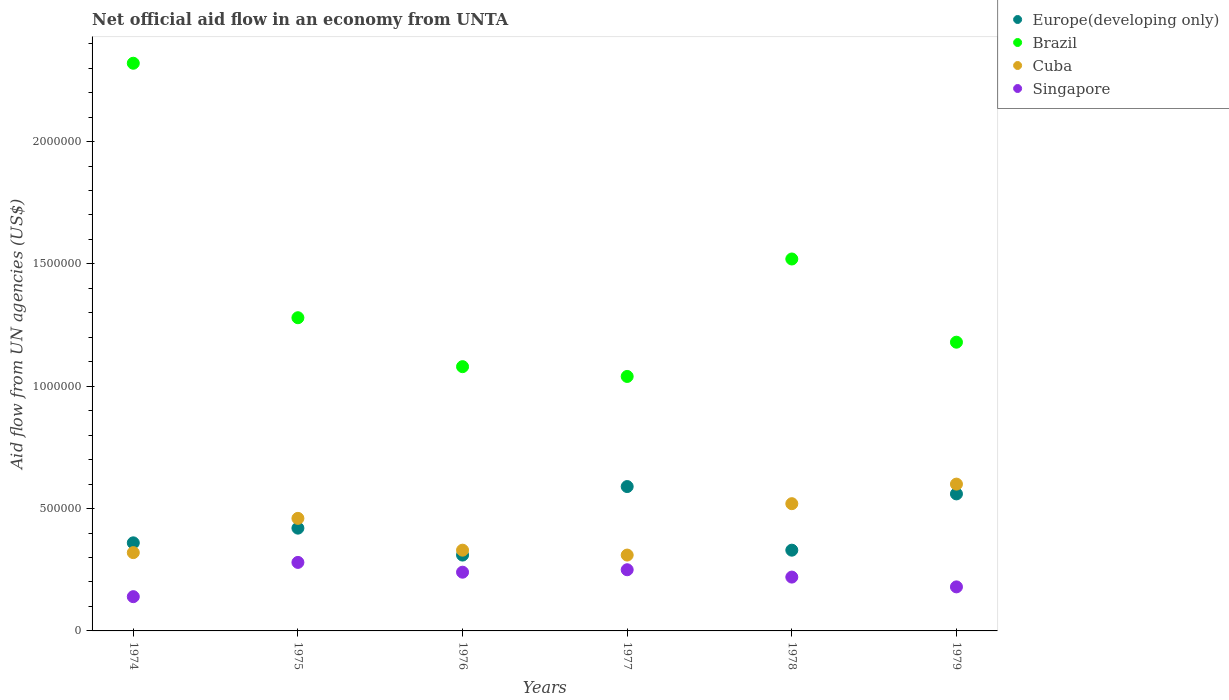What is the net official aid flow in Europe(developing only) in 1976?
Give a very brief answer. 3.10e+05. Across all years, what is the minimum net official aid flow in Cuba?
Make the answer very short. 3.10e+05. In which year was the net official aid flow in Cuba maximum?
Your response must be concise. 1979. In which year was the net official aid flow in Brazil minimum?
Your answer should be compact. 1977. What is the total net official aid flow in Brazil in the graph?
Provide a short and direct response. 8.42e+06. What is the difference between the net official aid flow in Singapore in 1979 and the net official aid flow in Cuba in 1977?
Make the answer very short. -1.30e+05. What is the average net official aid flow in Europe(developing only) per year?
Your answer should be very brief. 4.28e+05. What is the ratio of the net official aid flow in Europe(developing only) in 1976 to that in 1979?
Your response must be concise. 0.55. Is the net official aid flow in Europe(developing only) in 1974 less than that in 1977?
Keep it short and to the point. Yes. What is the difference between the highest and the lowest net official aid flow in Brazil?
Your response must be concise. 1.28e+06. In how many years, is the net official aid flow in Europe(developing only) greater than the average net official aid flow in Europe(developing only) taken over all years?
Your response must be concise. 2. Is the sum of the net official aid flow in Cuba in 1974 and 1979 greater than the maximum net official aid flow in Brazil across all years?
Offer a terse response. No. Is it the case that in every year, the sum of the net official aid flow in Cuba and net official aid flow in Europe(developing only)  is greater than the net official aid flow in Singapore?
Provide a short and direct response. Yes. Does the net official aid flow in Singapore monotonically increase over the years?
Your answer should be very brief. No. Is the net official aid flow in Singapore strictly less than the net official aid flow in Europe(developing only) over the years?
Offer a very short reply. Yes. How many dotlines are there?
Provide a short and direct response. 4. How many years are there in the graph?
Keep it short and to the point. 6. Does the graph contain any zero values?
Your answer should be compact. No. Does the graph contain grids?
Your answer should be compact. No. How many legend labels are there?
Your response must be concise. 4. What is the title of the graph?
Provide a succinct answer. Net official aid flow in an economy from UNTA. What is the label or title of the X-axis?
Offer a terse response. Years. What is the label or title of the Y-axis?
Give a very brief answer. Aid flow from UN agencies (US$). What is the Aid flow from UN agencies (US$) of Brazil in 1974?
Offer a terse response. 2.32e+06. What is the Aid flow from UN agencies (US$) of Cuba in 1974?
Provide a short and direct response. 3.20e+05. What is the Aid flow from UN agencies (US$) of Singapore in 1974?
Make the answer very short. 1.40e+05. What is the Aid flow from UN agencies (US$) of Europe(developing only) in 1975?
Make the answer very short. 4.20e+05. What is the Aid flow from UN agencies (US$) of Brazil in 1975?
Offer a very short reply. 1.28e+06. What is the Aid flow from UN agencies (US$) of Cuba in 1975?
Your answer should be compact. 4.60e+05. What is the Aid flow from UN agencies (US$) of Singapore in 1975?
Provide a succinct answer. 2.80e+05. What is the Aid flow from UN agencies (US$) in Europe(developing only) in 1976?
Provide a succinct answer. 3.10e+05. What is the Aid flow from UN agencies (US$) in Brazil in 1976?
Keep it short and to the point. 1.08e+06. What is the Aid flow from UN agencies (US$) of Cuba in 1976?
Offer a terse response. 3.30e+05. What is the Aid flow from UN agencies (US$) of Singapore in 1976?
Keep it short and to the point. 2.40e+05. What is the Aid flow from UN agencies (US$) in Europe(developing only) in 1977?
Ensure brevity in your answer.  5.90e+05. What is the Aid flow from UN agencies (US$) of Brazil in 1977?
Offer a terse response. 1.04e+06. What is the Aid flow from UN agencies (US$) in Brazil in 1978?
Keep it short and to the point. 1.52e+06. What is the Aid flow from UN agencies (US$) of Cuba in 1978?
Offer a terse response. 5.20e+05. What is the Aid flow from UN agencies (US$) of Singapore in 1978?
Provide a short and direct response. 2.20e+05. What is the Aid flow from UN agencies (US$) in Europe(developing only) in 1979?
Provide a succinct answer. 5.60e+05. What is the Aid flow from UN agencies (US$) of Brazil in 1979?
Ensure brevity in your answer.  1.18e+06. Across all years, what is the maximum Aid flow from UN agencies (US$) of Europe(developing only)?
Keep it short and to the point. 5.90e+05. Across all years, what is the maximum Aid flow from UN agencies (US$) of Brazil?
Your response must be concise. 2.32e+06. Across all years, what is the maximum Aid flow from UN agencies (US$) in Singapore?
Your answer should be very brief. 2.80e+05. Across all years, what is the minimum Aid flow from UN agencies (US$) in Brazil?
Keep it short and to the point. 1.04e+06. Across all years, what is the minimum Aid flow from UN agencies (US$) of Cuba?
Keep it short and to the point. 3.10e+05. Across all years, what is the minimum Aid flow from UN agencies (US$) of Singapore?
Offer a terse response. 1.40e+05. What is the total Aid flow from UN agencies (US$) in Europe(developing only) in the graph?
Provide a succinct answer. 2.57e+06. What is the total Aid flow from UN agencies (US$) in Brazil in the graph?
Ensure brevity in your answer.  8.42e+06. What is the total Aid flow from UN agencies (US$) in Cuba in the graph?
Offer a very short reply. 2.54e+06. What is the total Aid flow from UN agencies (US$) in Singapore in the graph?
Provide a short and direct response. 1.31e+06. What is the difference between the Aid flow from UN agencies (US$) of Europe(developing only) in 1974 and that in 1975?
Provide a short and direct response. -6.00e+04. What is the difference between the Aid flow from UN agencies (US$) in Brazil in 1974 and that in 1975?
Provide a succinct answer. 1.04e+06. What is the difference between the Aid flow from UN agencies (US$) of Europe(developing only) in 1974 and that in 1976?
Your answer should be compact. 5.00e+04. What is the difference between the Aid flow from UN agencies (US$) of Brazil in 1974 and that in 1976?
Provide a succinct answer. 1.24e+06. What is the difference between the Aid flow from UN agencies (US$) of Cuba in 1974 and that in 1976?
Provide a short and direct response. -10000. What is the difference between the Aid flow from UN agencies (US$) in Europe(developing only) in 1974 and that in 1977?
Make the answer very short. -2.30e+05. What is the difference between the Aid flow from UN agencies (US$) of Brazil in 1974 and that in 1977?
Ensure brevity in your answer.  1.28e+06. What is the difference between the Aid flow from UN agencies (US$) in Brazil in 1974 and that in 1978?
Your answer should be very brief. 8.00e+05. What is the difference between the Aid flow from UN agencies (US$) of Cuba in 1974 and that in 1978?
Your response must be concise. -2.00e+05. What is the difference between the Aid flow from UN agencies (US$) of Europe(developing only) in 1974 and that in 1979?
Offer a very short reply. -2.00e+05. What is the difference between the Aid flow from UN agencies (US$) of Brazil in 1974 and that in 1979?
Your response must be concise. 1.14e+06. What is the difference between the Aid flow from UN agencies (US$) in Cuba in 1974 and that in 1979?
Ensure brevity in your answer.  -2.80e+05. What is the difference between the Aid flow from UN agencies (US$) of Europe(developing only) in 1975 and that in 1976?
Your answer should be very brief. 1.10e+05. What is the difference between the Aid flow from UN agencies (US$) of Cuba in 1975 and that in 1976?
Make the answer very short. 1.30e+05. What is the difference between the Aid flow from UN agencies (US$) of Cuba in 1975 and that in 1977?
Ensure brevity in your answer.  1.50e+05. What is the difference between the Aid flow from UN agencies (US$) in Brazil in 1975 and that in 1978?
Give a very brief answer. -2.40e+05. What is the difference between the Aid flow from UN agencies (US$) of Singapore in 1975 and that in 1978?
Provide a succinct answer. 6.00e+04. What is the difference between the Aid flow from UN agencies (US$) of Europe(developing only) in 1975 and that in 1979?
Offer a very short reply. -1.40e+05. What is the difference between the Aid flow from UN agencies (US$) of Brazil in 1975 and that in 1979?
Provide a short and direct response. 1.00e+05. What is the difference between the Aid flow from UN agencies (US$) of Cuba in 1975 and that in 1979?
Offer a very short reply. -1.40e+05. What is the difference between the Aid flow from UN agencies (US$) in Europe(developing only) in 1976 and that in 1977?
Offer a very short reply. -2.80e+05. What is the difference between the Aid flow from UN agencies (US$) of Brazil in 1976 and that in 1977?
Your answer should be compact. 4.00e+04. What is the difference between the Aid flow from UN agencies (US$) of Europe(developing only) in 1976 and that in 1978?
Keep it short and to the point. -2.00e+04. What is the difference between the Aid flow from UN agencies (US$) of Brazil in 1976 and that in 1978?
Your answer should be very brief. -4.40e+05. What is the difference between the Aid flow from UN agencies (US$) in Singapore in 1976 and that in 1978?
Give a very brief answer. 2.00e+04. What is the difference between the Aid flow from UN agencies (US$) in Europe(developing only) in 1976 and that in 1979?
Keep it short and to the point. -2.50e+05. What is the difference between the Aid flow from UN agencies (US$) of Singapore in 1976 and that in 1979?
Give a very brief answer. 6.00e+04. What is the difference between the Aid flow from UN agencies (US$) in Europe(developing only) in 1977 and that in 1978?
Ensure brevity in your answer.  2.60e+05. What is the difference between the Aid flow from UN agencies (US$) of Brazil in 1977 and that in 1978?
Provide a short and direct response. -4.80e+05. What is the difference between the Aid flow from UN agencies (US$) of Europe(developing only) in 1977 and that in 1979?
Make the answer very short. 3.00e+04. What is the difference between the Aid flow from UN agencies (US$) in Brazil in 1977 and that in 1979?
Give a very brief answer. -1.40e+05. What is the difference between the Aid flow from UN agencies (US$) of Singapore in 1977 and that in 1979?
Give a very brief answer. 7.00e+04. What is the difference between the Aid flow from UN agencies (US$) of Europe(developing only) in 1978 and that in 1979?
Keep it short and to the point. -2.30e+05. What is the difference between the Aid flow from UN agencies (US$) of Singapore in 1978 and that in 1979?
Provide a succinct answer. 4.00e+04. What is the difference between the Aid flow from UN agencies (US$) in Europe(developing only) in 1974 and the Aid flow from UN agencies (US$) in Brazil in 1975?
Keep it short and to the point. -9.20e+05. What is the difference between the Aid flow from UN agencies (US$) in Europe(developing only) in 1974 and the Aid flow from UN agencies (US$) in Cuba in 1975?
Give a very brief answer. -1.00e+05. What is the difference between the Aid flow from UN agencies (US$) in Europe(developing only) in 1974 and the Aid flow from UN agencies (US$) in Singapore in 1975?
Provide a short and direct response. 8.00e+04. What is the difference between the Aid flow from UN agencies (US$) of Brazil in 1974 and the Aid flow from UN agencies (US$) of Cuba in 1975?
Provide a succinct answer. 1.86e+06. What is the difference between the Aid flow from UN agencies (US$) in Brazil in 1974 and the Aid flow from UN agencies (US$) in Singapore in 1975?
Make the answer very short. 2.04e+06. What is the difference between the Aid flow from UN agencies (US$) in Europe(developing only) in 1974 and the Aid flow from UN agencies (US$) in Brazil in 1976?
Provide a succinct answer. -7.20e+05. What is the difference between the Aid flow from UN agencies (US$) of Europe(developing only) in 1974 and the Aid flow from UN agencies (US$) of Cuba in 1976?
Provide a short and direct response. 3.00e+04. What is the difference between the Aid flow from UN agencies (US$) of Brazil in 1974 and the Aid flow from UN agencies (US$) of Cuba in 1976?
Ensure brevity in your answer.  1.99e+06. What is the difference between the Aid flow from UN agencies (US$) of Brazil in 1974 and the Aid flow from UN agencies (US$) of Singapore in 1976?
Provide a succinct answer. 2.08e+06. What is the difference between the Aid flow from UN agencies (US$) of Cuba in 1974 and the Aid flow from UN agencies (US$) of Singapore in 1976?
Give a very brief answer. 8.00e+04. What is the difference between the Aid flow from UN agencies (US$) in Europe(developing only) in 1974 and the Aid flow from UN agencies (US$) in Brazil in 1977?
Offer a terse response. -6.80e+05. What is the difference between the Aid flow from UN agencies (US$) of Europe(developing only) in 1974 and the Aid flow from UN agencies (US$) of Singapore in 1977?
Offer a terse response. 1.10e+05. What is the difference between the Aid flow from UN agencies (US$) of Brazil in 1974 and the Aid flow from UN agencies (US$) of Cuba in 1977?
Provide a succinct answer. 2.01e+06. What is the difference between the Aid flow from UN agencies (US$) in Brazil in 1974 and the Aid flow from UN agencies (US$) in Singapore in 1977?
Keep it short and to the point. 2.07e+06. What is the difference between the Aid flow from UN agencies (US$) in Europe(developing only) in 1974 and the Aid flow from UN agencies (US$) in Brazil in 1978?
Your answer should be very brief. -1.16e+06. What is the difference between the Aid flow from UN agencies (US$) of Europe(developing only) in 1974 and the Aid flow from UN agencies (US$) of Cuba in 1978?
Offer a very short reply. -1.60e+05. What is the difference between the Aid flow from UN agencies (US$) of Brazil in 1974 and the Aid flow from UN agencies (US$) of Cuba in 1978?
Your answer should be very brief. 1.80e+06. What is the difference between the Aid flow from UN agencies (US$) of Brazil in 1974 and the Aid flow from UN agencies (US$) of Singapore in 1978?
Keep it short and to the point. 2.10e+06. What is the difference between the Aid flow from UN agencies (US$) in Europe(developing only) in 1974 and the Aid flow from UN agencies (US$) in Brazil in 1979?
Provide a succinct answer. -8.20e+05. What is the difference between the Aid flow from UN agencies (US$) of Europe(developing only) in 1974 and the Aid flow from UN agencies (US$) of Singapore in 1979?
Offer a terse response. 1.80e+05. What is the difference between the Aid flow from UN agencies (US$) in Brazil in 1974 and the Aid flow from UN agencies (US$) in Cuba in 1979?
Provide a succinct answer. 1.72e+06. What is the difference between the Aid flow from UN agencies (US$) in Brazil in 1974 and the Aid flow from UN agencies (US$) in Singapore in 1979?
Ensure brevity in your answer.  2.14e+06. What is the difference between the Aid flow from UN agencies (US$) of Europe(developing only) in 1975 and the Aid flow from UN agencies (US$) of Brazil in 1976?
Offer a very short reply. -6.60e+05. What is the difference between the Aid flow from UN agencies (US$) in Europe(developing only) in 1975 and the Aid flow from UN agencies (US$) in Cuba in 1976?
Keep it short and to the point. 9.00e+04. What is the difference between the Aid flow from UN agencies (US$) in Europe(developing only) in 1975 and the Aid flow from UN agencies (US$) in Singapore in 1976?
Provide a succinct answer. 1.80e+05. What is the difference between the Aid flow from UN agencies (US$) in Brazil in 1975 and the Aid flow from UN agencies (US$) in Cuba in 1976?
Give a very brief answer. 9.50e+05. What is the difference between the Aid flow from UN agencies (US$) of Brazil in 1975 and the Aid flow from UN agencies (US$) of Singapore in 1976?
Offer a terse response. 1.04e+06. What is the difference between the Aid flow from UN agencies (US$) in Europe(developing only) in 1975 and the Aid flow from UN agencies (US$) in Brazil in 1977?
Your answer should be compact. -6.20e+05. What is the difference between the Aid flow from UN agencies (US$) in Europe(developing only) in 1975 and the Aid flow from UN agencies (US$) in Cuba in 1977?
Your answer should be compact. 1.10e+05. What is the difference between the Aid flow from UN agencies (US$) of Europe(developing only) in 1975 and the Aid flow from UN agencies (US$) of Singapore in 1977?
Your answer should be compact. 1.70e+05. What is the difference between the Aid flow from UN agencies (US$) of Brazil in 1975 and the Aid flow from UN agencies (US$) of Cuba in 1977?
Provide a succinct answer. 9.70e+05. What is the difference between the Aid flow from UN agencies (US$) of Brazil in 1975 and the Aid flow from UN agencies (US$) of Singapore in 1977?
Offer a very short reply. 1.03e+06. What is the difference between the Aid flow from UN agencies (US$) in Europe(developing only) in 1975 and the Aid flow from UN agencies (US$) in Brazil in 1978?
Your response must be concise. -1.10e+06. What is the difference between the Aid flow from UN agencies (US$) of Europe(developing only) in 1975 and the Aid flow from UN agencies (US$) of Cuba in 1978?
Your answer should be very brief. -1.00e+05. What is the difference between the Aid flow from UN agencies (US$) of Brazil in 1975 and the Aid flow from UN agencies (US$) of Cuba in 1978?
Provide a short and direct response. 7.60e+05. What is the difference between the Aid flow from UN agencies (US$) of Brazil in 1975 and the Aid flow from UN agencies (US$) of Singapore in 1978?
Ensure brevity in your answer.  1.06e+06. What is the difference between the Aid flow from UN agencies (US$) in Europe(developing only) in 1975 and the Aid flow from UN agencies (US$) in Brazil in 1979?
Your answer should be compact. -7.60e+05. What is the difference between the Aid flow from UN agencies (US$) of Brazil in 1975 and the Aid flow from UN agencies (US$) of Cuba in 1979?
Give a very brief answer. 6.80e+05. What is the difference between the Aid flow from UN agencies (US$) in Brazil in 1975 and the Aid flow from UN agencies (US$) in Singapore in 1979?
Give a very brief answer. 1.10e+06. What is the difference between the Aid flow from UN agencies (US$) in Cuba in 1975 and the Aid flow from UN agencies (US$) in Singapore in 1979?
Your answer should be very brief. 2.80e+05. What is the difference between the Aid flow from UN agencies (US$) of Europe(developing only) in 1976 and the Aid flow from UN agencies (US$) of Brazil in 1977?
Your answer should be compact. -7.30e+05. What is the difference between the Aid flow from UN agencies (US$) of Brazil in 1976 and the Aid flow from UN agencies (US$) of Cuba in 1977?
Ensure brevity in your answer.  7.70e+05. What is the difference between the Aid flow from UN agencies (US$) in Brazil in 1976 and the Aid flow from UN agencies (US$) in Singapore in 1977?
Your response must be concise. 8.30e+05. What is the difference between the Aid flow from UN agencies (US$) in Europe(developing only) in 1976 and the Aid flow from UN agencies (US$) in Brazil in 1978?
Keep it short and to the point. -1.21e+06. What is the difference between the Aid flow from UN agencies (US$) in Brazil in 1976 and the Aid flow from UN agencies (US$) in Cuba in 1978?
Offer a very short reply. 5.60e+05. What is the difference between the Aid flow from UN agencies (US$) of Brazil in 1976 and the Aid flow from UN agencies (US$) of Singapore in 1978?
Ensure brevity in your answer.  8.60e+05. What is the difference between the Aid flow from UN agencies (US$) of Europe(developing only) in 1976 and the Aid flow from UN agencies (US$) of Brazil in 1979?
Offer a very short reply. -8.70e+05. What is the difference between the Aid flow from UN agencies (US$) in Europe(developing only) in 1976 and the Aid flow from UN agencies (US$) in Cuba in 1979?
Your response must be concise. -2.90e+05. What is the difference between the Aid flow from UN agencies (US$) in Brazil in 1976 and the Aid flow from UN agencies (US$) in Singapore in 1979?
Offer a very short reply. 9.00e+05. What is the difference between the Aid flow from UN agencies (US$) in Europe(developing only) in 1977 and the Aid flow from UN agencies (US$) in Brazil in 1978?
Make the answer very short. -9.30e+05. What is the difference between the Aid flow from UN agencies (US$) of Europe(developing only) in 1977 and the Aid flow from UN agencies (US$) of Cuba in 1978?
Offer a very short reply. 7.00e+04. What is the difference between the Aid flow from UN agencies (US$) of Europe(developing only) in 1977 and the Aid flow from UN agencies (US$) of Singapore in 1978?
Provide a succinct answer. 3.70e+05. What is the difference between the Aid flow from UN agencies (US$) of Brazil in 1977 and the Aid flow from UN agencies (US$) of Cuba in 1978?
Your answer should be very brief. 5.20e+05. What is the difference between the Aid flow from UN agencies (US$) in Brazil in 1977 and the Aid flow from UN agencies (US$) in Singapore in 1978?
Provide a succinct answer. 8.20e+05. What is the difference between the Aid flow from UN agencies (US$) in Europe(developing only) in 1977 and the Aid flow from UN agencies (US$) in Brazil in 1979?
Keep it short and to the point. -5.90e+05. What is the difference between the Aid flow from UN agencies (US$) of Europe(developing only) in 1977 and the Aid flow from UN agencies (US$) of Singapore in 1979?
Your answer should be compact. 4.10e+05. What is the difference between the Aid flow from UN agencies (US$) of Brazil in 1977 and the Aid flow from UN agencies (US$) of Singapore in 1979?
Offer a terse response. 8.60e+05. What is the difference between the Aid flow from UN agencies (US$) of Cuba in 1977 and the Aid flow from UN agencies (US$) of Singapore in 1979?
Your response must be concise. 1.30e+05. What is the difference between the Aid flow from UN agencies (US$) in Europe(developing only) in 1978 and the Aid flow from UN agencies (US$) in Brazil in 1979?
Your response must be concise. -8.50e+05. What is the difference between the Aid flow from UN agencies (US$) in Brazil in 1978 and the Aid flow from UN agencies (US$) in Cuba in 1979?
Offer a terse response. 9.20e+05. What is the difference between the Aid flow from UN agencies (US$) of Brazil in 1978 and the Aid flow from UN agencies (US$) of Singapore in 1979?
Keep it short and to the point. 1.34e+06. What is the average Aid flow from UN agencies (US$) of Europe(developing only) per year?
Your answer should be very brief. 4.28e+05. What is the average Aid flow from UN agencies (US$) of Brazil per year?
Make the answer very short. 1.40e+06. What is the average Aid flow from UN agencies (US$) of Cuba per year?
Provide a succinct answer. 4.23e+05. What is the average Aid flow from UN agencies (US$) in Singapore per year?
Ensure brevity in your answer.  2.18e+05. In the year 1974, what is the difference between the Aid flow from UN agencies (US$) of Europe(developing only) and Aid flow from UN agencies (US$) of Brazil?
Make the answer very short. -1.96e+06. In the year 1974, what is the difference between the Aid flow from UN agencies (US$) of Europe(developing only) and Aid flow from UN agencies (US$) of Cuba?
Give a very brief answer. 4.00e+04. In the year 1974, what is the difference between the Aid flow from UN agencies (US$) of Brazil and Aid flow from UN agencies (US$) of Singapore?
Ensure brevity in your answer.  2.18e+06. In the year 1975, what is the difference between the Aid flow from UN agencies (US$) in Europe(developing only) and Aid flow from UN agencies (US$) in Brazil?
Your response must be concise. -8.60e+05. In the year 1975, what is the difference between the Aid flow from UN agencies (US$) of Europe(developing only) and Aid flow from UN agencies (US$) of Cuba?
Your response must be concise. -4.00e+04. In the year 1975, what is the difference between the Aid flow from UN agencies (US$) in Europe(developing only) and Aid flow from UN agencies (US$) in Singapore?
Provide a short and direct response. 1.40e+05. In the year 1975, what is the difference between the Aid flow from UN agencies (US$) in Brazil and Aid flow from UN agencies (US$) in Cuba?
Your answer should be compact. 8.20e+05. In the year 1975, what is the difference between the Aid flow from UN agencies (US$) in Brazil and Aid flow from UN agencies (US$) in Singapore?
Provide a short and direct response. 1.00e+06. In the year 1975, what is the difference between the Aid flow from UN agencies (US$) in Cuba and Aid flow from UN agencies (US$) in Singapore?
Ensure brevity in your answer.  1.80e+05. In the year 1976, what is the difference between the Aid flow from UN agencies (US$) of Europe(developing only) and Aid flow from UN agencies (US$) of Brazil?
Offer a terse response. -7.70e+05. In the year 1976, what is the difference between the Aid flow from UN agencies (US$) in Europe(developing only) and Aid flow from UN agencies (US$) in Cuba?
Make the answer very short. -2.00e+04. In the year 1976, what is the difference between the Aid flow from UN agencies (US$) in Brazil and Aid flow from UN agencies (US$) in Cuba?
Offer a terse response. 7.50e+05. In the year 1976, what is the difference between the Aid flow from UN agencies (US$) of Brazil and Aid flow from UN agencies (US$) of Singapore?
Ensure brevity in your answer.  8.40e+05. In the year 1977, what is the difference between the Aid flow from UN agencies (US$) in Europe(developing only) and Aid flow from UN agencies (US$) in Brazil?
Provide a succinct answer. -4.50e+05. In the year 1977, what is the difference between the Aid flow from UN agencies (US$) of Brazil and Aid flow from UN agencies (US$) of Cuba?
Keep it short and to the point. 7.30e+05. In the year 1977, what is the difference between the Aid flow from UN agencies (US$) in Brazil and Aid flow from UN agencies (US$) in Singapore?
Offer a terse response. 7.90e+05. In the year 1978, what is the difference between the Aid flow from UN agencies (US$) in Europe(developing only) and Aid flow from UN agencies (US$) in Brazil?
Your response must be concise. -1.19e+06. In the year 1978, what is the difference between the Aid flow from UN agencies (US$) in Europe(developing only) and Aid flow from UN agencies (US$) in Cuba?
Your response must be concise. -1.90e+05. In the year 1978, what is the difference between the Aid flow from UN agencies (US$) of Europe(developing only) and Aid flow from UN agencies (US$) of Singapore?
Keep it short and to the point. 1.10e+05. In the year 1978, what is the difference between the Aid flow from UN agencies (US$) of Brazil and Aid flow from UN agencies (US$) of Cuba?
Your answer should be compact. 1.00e+06. In the year 1978, what is the difference between the Aid flow from UN agencies (US$) of Brazil and Aid flow from UN agencies (US$) of Singapore?
Your answer should be very brief. 1.30e+06. In the year 1979, what is the difference between the Aid flow from UN agencies (US$) of Europe(developing only) and Aid flow from UN agencies (US$) of Brazil?
Provide a succinct answer. -6.20e+05. In the year 1979, what is the difference between the Aid flow from UN agencies (US$) of Brazil and Aid flow from UN agencies (US$) of Cuba?
Make the answer very short. 5.80e+05. In the year 1979, what is the difference between the Aid flow from UN agencies (US$) in Brazil and Aid flow from UN agencies (US$) in Singapore?
Your response must be concise. 1.00e+06. In the year 1979, what is the difference between the Aid flow from UN agencies (US$) in Cuba and Aid flow from UN agencies (US$) in Singapore?
Your response must be concise. 4.20e+05. What is the ratio of the Aid flow from UN agencies (US$) of Brazil in 1974 to that in 1975?
Your answer should be very brief. 1.81. What is the ratio of the Aid flow from UN agencies (US$) of Cuba in 1974 to that in 1975?
Offer a very short reply. 0.7. What is the ratio of the Aid flow from UN agencies (US$) in Europe(developing only) in 1974 to that in 1976?
Provide a succinct answer. 1.16. What is the ratio of the Aid flow from UN agencies (US$) of Brazil in 1974 to that in 1976?
Your response must be concise. 2.15. What is the ratio of the Aid flow from UN agencies (US$) in Cuba in 1974 to that in 1976?
Offer a terse response. 0.97. What is the ratio of the Aid flow from UN agencies (US$) in Singapore in 1974 to that in 1976?
Offer a terse response. 0.58. What is the ratio of the Aid flow from UN agencies (US$) in Europe(developing only) in 1974 to that in 1977?
Your response must be concise. 0.61. What is the ratio of the Aid flow from UN agencies (US$) in Brazil in 1974 to that in 1977?
Your response must be concise. 2.23. What is the ratio of the Aid flow from UN agencies (US$) in Cuba in 1974 to that in 1977?
Keep it short and to the point. 1.03. What is the ratio of the Aid flow from UN agencies (US$) of Singapore in 1974 to that in 1977?
Make the answer very short. 0.56. What is the ratio of the Aid flow from UN agencies (US$) of Europe(developing only) in 1974 to that in 1978?
Give a very brief answer. 1.09. What is the ratio of the Aid flow from UN agencies (US$) of Brazil in 1974 to that in 1978?
Offer a very short reply. 1.53. What is the ratio of the Aid flow from UN agencies (US$) of Cuba in 1974 to that in 1978?
Offer a very short reply. 0.62. What is the ratio of the Aid flow from UN agencies (US$) in Singapore in 1974 to that in 1978?
Give a very brief answer. 0.64. What is the ratio of the Aid flow from UN agencies (US$) of Europe(developing only) in 1974 to that in 1979?
Your answer should be compact. 0.64. What is the ratio of the Aid flow from UN agencies (US$) of Brazil in 1974 to that in 1979?
Give a very brief answer. 1.97. What is the ratio of the Aid flow from UN agencies (US$) in Cuba in 1974 to that in 1979?
Your answer should be compact. 0.53. What is the ratio of the Aid flow from UN agencies (US$) of Singapore in 1974 to that in 1979?
Offer a very short reply. 0.78. What is the ratio of the Aid flow from UN agencies (US$) in Europe(developing only) in 1975 to that in 1976?
Give a very brief answer. 1.35. What is the ratio of the Aid flow from UN agencies (US$) of Brazil in 1975 to that in 1976?
Make the answer very short. 1.19. What is the ratio of the Aid flow from UN agencies (US$) in Cuba in 1975 to that in 1976?
Your response must be concise. 1.39. What is the ratio of the Aid flow from UN agencies (US$) in Singapore in 1975 to that in 1976?
Offer a very short reply. 1.17. What is the ratio of the Aid flow from UN agencies (US$) of Europe(developing only) in 1975 to that in 1977?
Your response must be concise. 0.71. What is the ratio of the Aid flow from UN agencies (US$) of Brazil in 1975 to that in 1977?
Make the answer very short. 1.23. What is the ratio of the Aid flow from UN agencies (US$) in Cuba in 1975 to that in 1977?
Offer a very short reply. 1.48. What is the ratio of the Aid flow from UN agencies (US$) of Singapore in 1975 to that in 1977?
Ensure brevity in your answer.  1.12. What is the ratio of the Aid flow from UN agencies (US$) in Europe(developing only) in 1975 to that in 1978?
Keep it short and to the point. 1.27. What is the ratio of the Aid flow from UN agencies (US$) in Brazil in 1975 to that in 1978?
Offer a very short reply. 0.84. What is the ratio of the Aid flow from UN agencies (US$) in Cuba in 1975 to that in 1978?
Offer a very short reply. 0.88. What is the ratio of the Aid flow from UN agencies (US$) of Singapore in 1975 to that in 1978?
Make the answer very short. 1.27. What is the ratio of the Aid flow from UN agencies (US$) in Brazil in 1975 to that in 1979?
Your response must be concise. 1.08. What is the ratio of the Aid flow from UN agencies (US$) in Cuba in 1975 to that in 1979?
Your response must be concise. 0.77. What is the ratio of the Aid flow from UN agencies (US$) in Singapore in 1975 to that in 1979?
Offer a very short reply. 1.56. What is the ratio of the Aid flow from UN agencies (US$) of Europe(developing only) in 1976 to that in 1977?
Provide a short and direct response. 0.53. What is the ratio of the Aid flow from UN agencies (US$) of Brazil in 1976 to that in 1977?
Provide a succinct answer. 1.04. What is the ratio of the Aid flow from UN agencies (US$) of Cuba in 1976 to that in 1977?
Your response must be concise. 1.06. What is the ratio of the Aid flow from UN agencies (US$) in Europe(developing only) in 1976 to that in 1978?
Your answer should be compact. 0.94. What is the ratio of the Aid flow from UN agencies (US$) of Brazil in 1976 to that in 1978?
Provide a succinct answer. 0.71. What is the ratio of the Aid flow from UN agencies (US$) of Cuba in 1976 to that in 1978?
Keep it short and to the point. 0.63. What is the ratio of the Aid flow from UN agencies (US$) of Singapore in 1976 to that in 1978?
Your answer should be compact. 1.09. What is the ratio of the Aid flow from UN agencies (US$) of Europe(developing only) in 1976 to that in 1979?
Keep it short and to the point. 0.55. What is the ratio of the Aid flow from UN agencies (US$) of Brazil in 1976 to that in 1979?
Ensure brevity in your answer.  0.92. What is the ratio of the Aid flow from UN agencies (US$) in Cuba in 1976 to that in 1979?
Make the answer very short. 0.55. What is the ratio of the Aid flow from UN agencies (US$) of Singapore in 1976 to that in 1979?
Provide a succinct answer. 1.33. What is the ratio of the Aid flow from UN agencies (US$) in Europe(developing only) in 1977 to that in 1978?
Offer a terse response. 1.79. What is the ratio of the Aid flow from UN agencies (US$) of Brazil in 1977 to that in 1978?
Ensure brevity in your answer.  0.68. What is the ratio of the Aid flow from UN agencies (US$) in Cuba in 1977 to that in 1978?
Give a very brief answer. 0.6. What is the ratio of the Aid flow from UN agencies (US$) of Singapore in 1977 to that in 1978?
Offer a terse response. 1.14. What is the ratio of the Aid flow from UN agencies (US$) of Europe(developing only) in 1977 to that in 1979?
Your answer should be compact. 1.05. What is the ratio of the Aid flow from UN agencies (US$) in Brazil in 1977 to that in 1979?
Keep it short and to the point. 0.88. What is the ratio of the Aid flow from UN agencies (US$) in Cuba in 1977 to that in 1979?
Ensure brevity in your answer.  0.52. What is the ratio of the Aid flow from UN agencies (US$) in Singapore in 1977 to that in 1979?
Your response must be concise. 1.39. What is the ratio of the Aid flow from UN agencies (US$) of Europe(developing only) in 1978 to that in 1979?
Give a very brief answer. 0.59. What is the ratio of the Aid flow from UN agencies (US$) in Brazil in 1978 to that in 1979?
Offer a terse response. 1.29. What is the ratio of the Aid flow from UN agencies (US$) of Cuba in 1978 to that in 1979?
Your answer should be compact. 0.87. What is the ratio of the Aid flow from UN agencies (US$) of Singapore in 1978 to that in 1979?
Give a very brief answer. 1.22. What is the difference between the highest and the second highest Aid flow from UN agencies (US$) of Europe(developing only)?
Your response must be concise. 3.00e+04. What is the difference between the highest and the second highest Aid flow from UN agencies (US$) of Cuba?
Your answer should be very brief. 8.00e+04. What is the difference between the highest and the second highest Aid flow from UN agencies (US$) in Singapore?
Ensure brevity in your answer.  3.00e+04. What is the difference between the highest and the lowest Aid flow from UN agencies (US$) of Europe(developing only)?
Provide a succinct answer. 2.80e+05. What is the difference between the highest and the lowest Aid flow from UN agencies (US$) in Brazil?
Your answer should be compact. 1.28e+06. What is the difference between the highest and the lowest Aid flow from UN agencies (US$) in Cuba?
Keep it short and to the point. 2.90e+05. What is the difference between the highest and the lowest Aid flow from UN agencies (US$) of Singapore?
Your answer should be compact. 1.40e+05. 